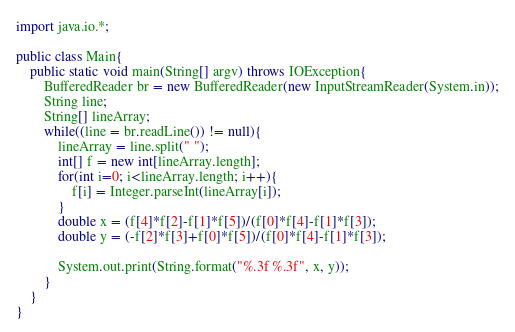Convert code to text. <code><loc_0><loc_0><loc_500><loc_500><_Java_>import java.io.*;

public class Main{
	public static void main(String[] argv) throws IOException{
		BufferedReader br = new BufferedReader(new InputStreamReader(System.in));
		String line;
		String[] lineArray;
		while((line = br.readLine()) != null){
			lineArray = line.split(" ");
			int[] f = new int[lineArray.length];
			for(int i=0; i<lineArray.length; i++){
				f[i] = Integer.parseInt(lineArray[i]);
			}
			double x = (f[4]*f[2]-f[1]*f[5])/(f[0]*f[4]-f[1]*f[3]);
			double y = (-f[2]*f[3]+f[0]*f[5])/(f[0]*f[4]-f[1]*f[3]);
			
			System.out.print(String.format("%.3f %.3f", x, y));
		}
	}
}</code> 